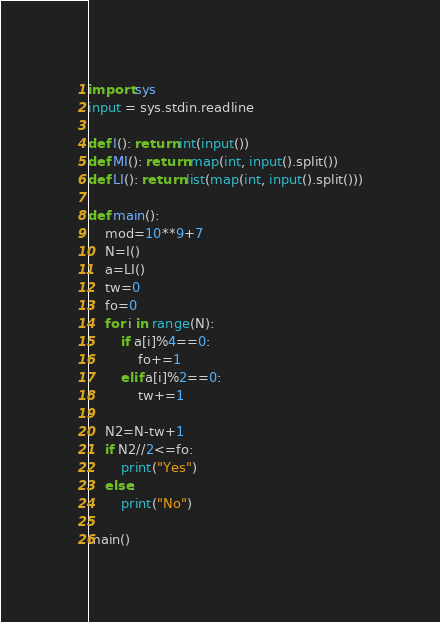Convert code to text. <code><loc_0><loc_0><loc_500><loc_500><_Python_>import sys
input = sys.stdin.readline

def I(): return int(input())
def MI(): return map(int, input().split())
def LI(): return list(map(int, input().split()))

def main():
    mod=10**9+7
    N=I()
    a=LI()
    tw=0
    fo=0
    for i in range(N):
        if a[i]%4==0:
            fo+=1
        elif a[i]%2==0:
            tw+=1
            
    N2=N-tw+1
    if N2//2<=fo:
        print("Yes")
    else:
        print("No")

main()
</code> 